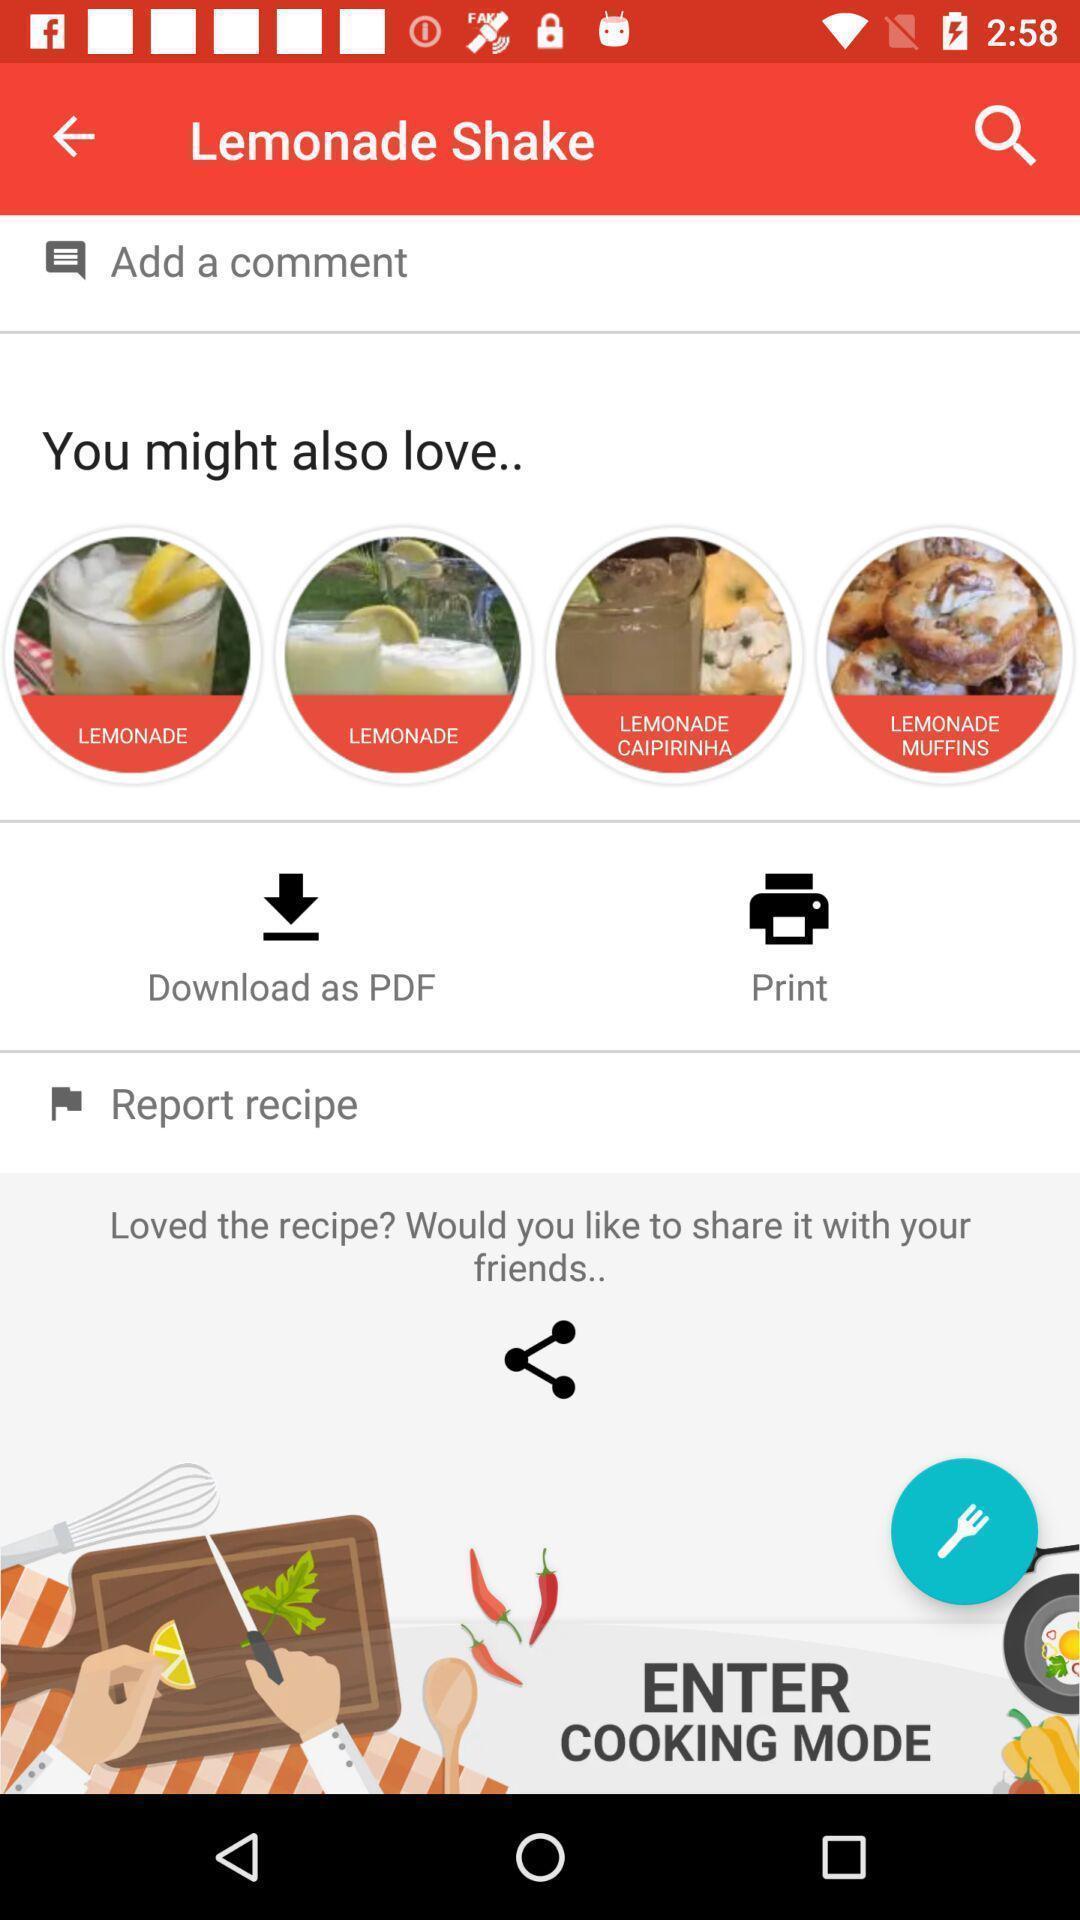Tell me what you see in this picture. Screen shows about diabetic recipe app. 